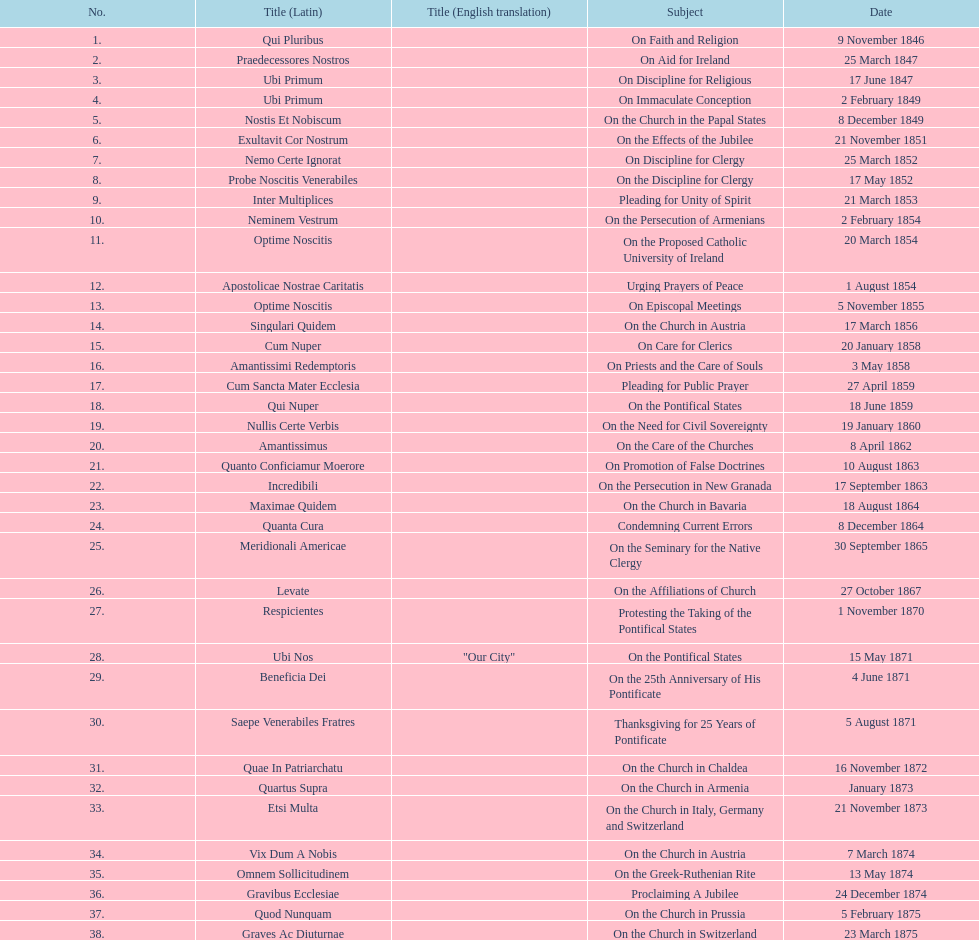In the first 10 years of his reign, how many encyclicals did pope pius ix issue? 14. 